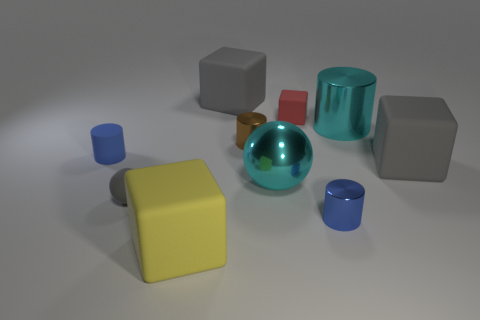Is the number of large cubes in front of the rubber cylinder greater than the number of large balls?
Ensure brevity in your answer.  Yes. Do the red rubber thing and the big gray thing behind the large cylinder have the same shape?
Your answer should be compact. Yes. How many tiny things are red shiny objects or blue cylinders?
Make the answer very short. 2. The shiny object that is the same color as the metallic sphere is what size?
Provide a short and direct response. Large. There is a metallic thing behind the tiny brown object that is in front of the red matte cube; what color is it?
Offer a terse response. Cyan. Is the tiny block made of the same material as the blue cylinder that is on the left side of the brown metal object?
Your answer should be compact. Yes. What is the big block that is behind the red thing made of?
Provide a succinct answer. Rubber. Are there the same number of small matte things in front of the small gray matte sphere and gray matte objects?
Provide a short and direct response. No. Is there anything else that has the same size as the brown thing?
Offer a terse response. Yes. There is a large cube that is in front of the gray rubber cube on the right side of the brown shiny cylinder; what is its material?
Provide a short and direct response. Rubber. 